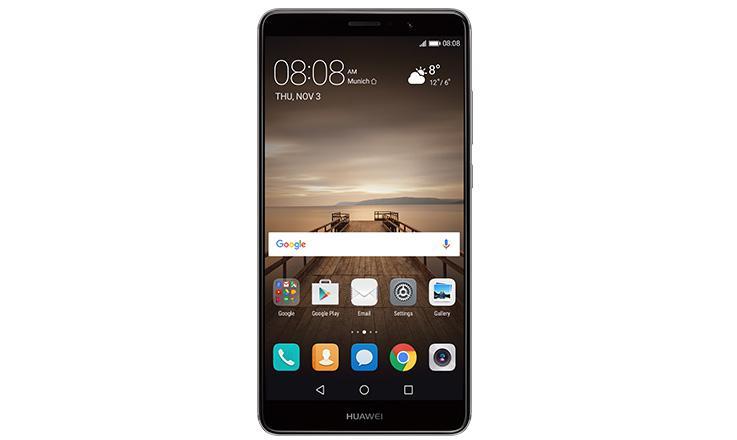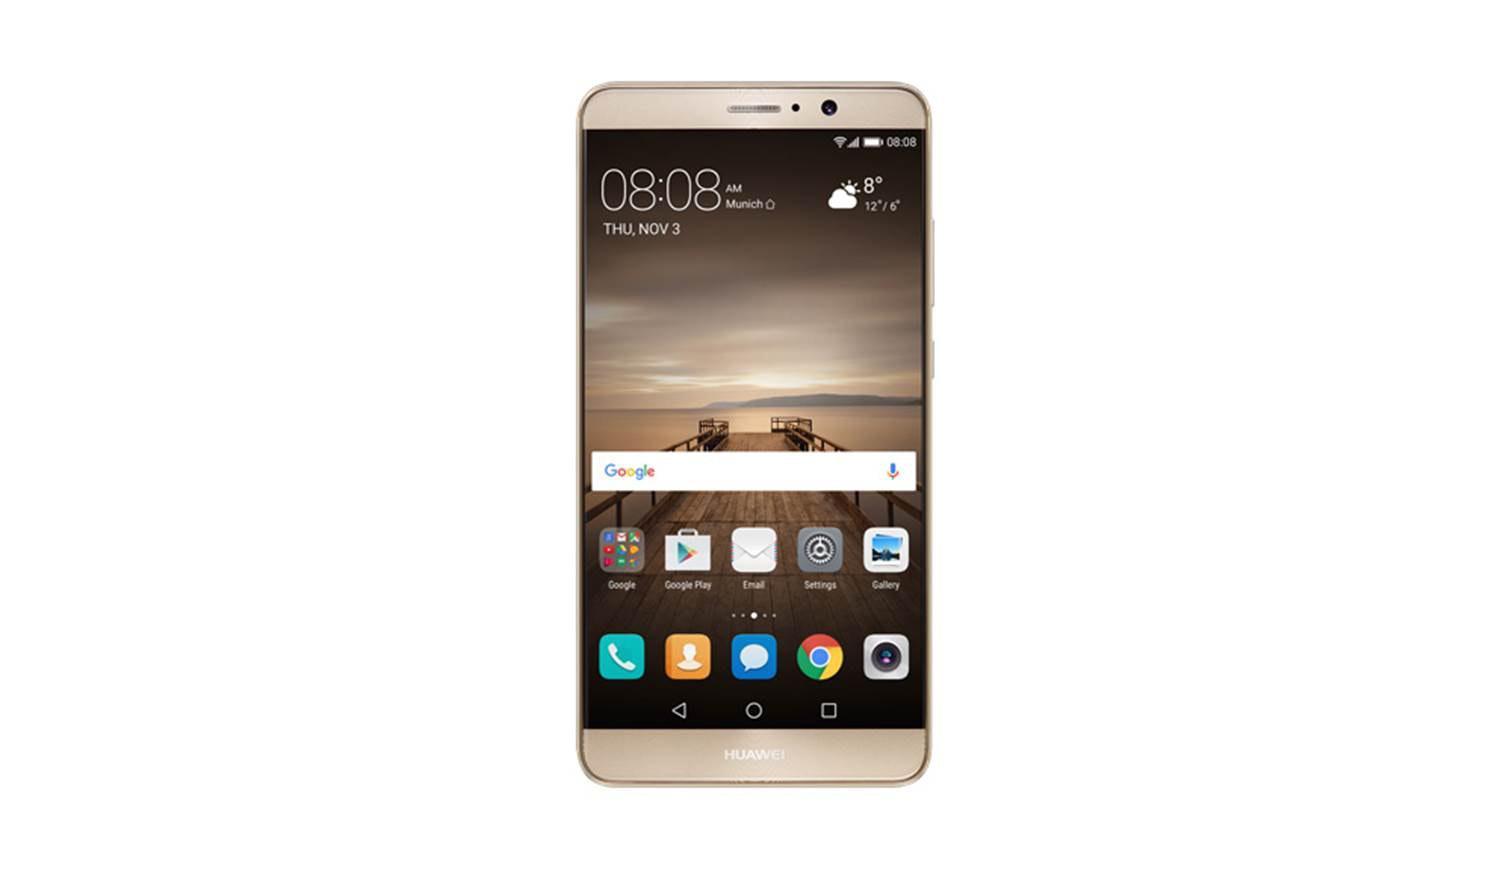The first image is the image on the left, the second image is the image on the right. Analyze the images presented: Is the assertion "One image shows the front and the back of a smartphone and the other shows only the front of a smartphone." valid? Answer yes or no. No. The first image is the image on the left, the second image is the image on the right. Examine the images to the left and right. Is the description "The left image shows a phone screen side-up that is on the right and overlapping a back-turned phone, and the right image shows only a phone's screen side." accurate? Answer yes or no. No. 